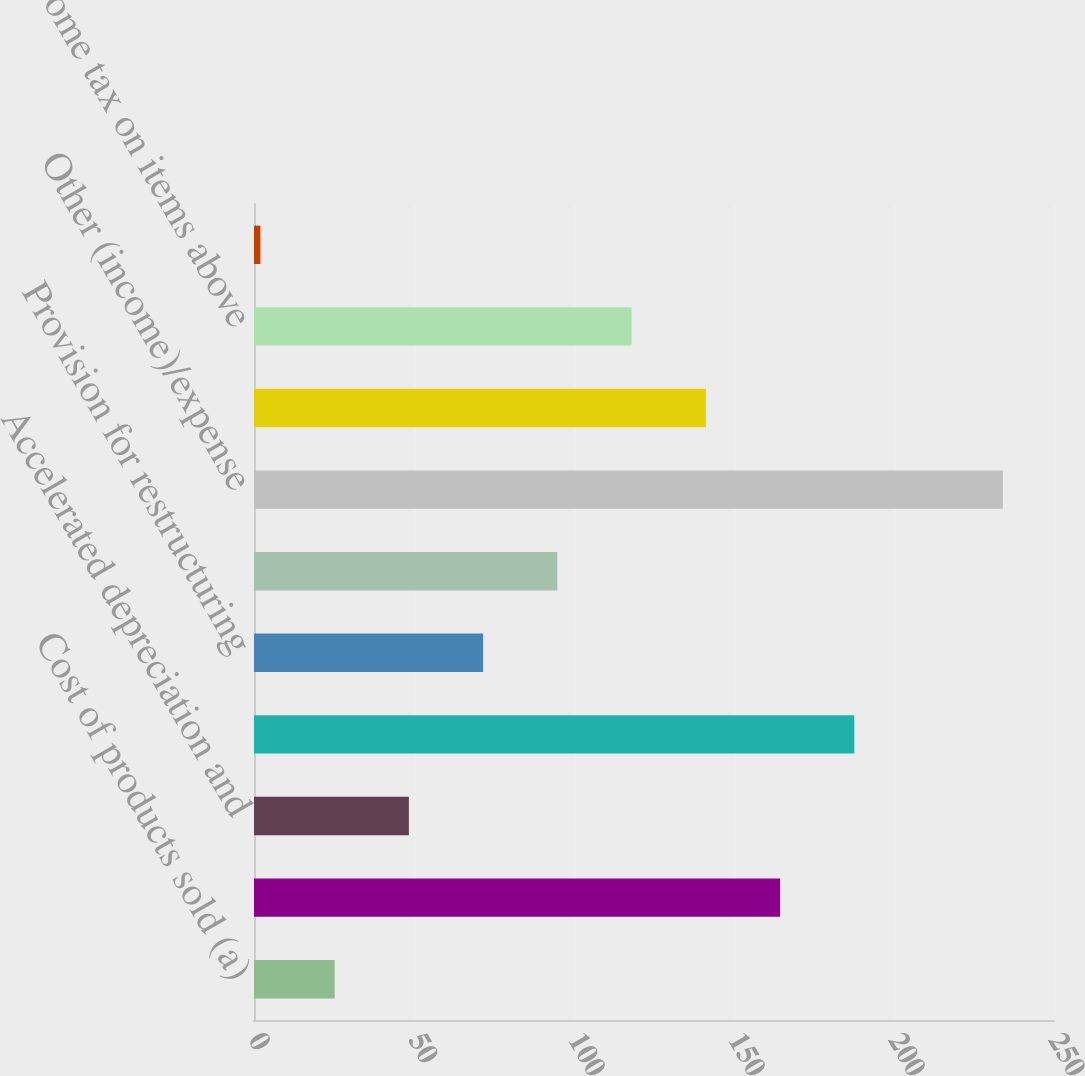<chart> <loc_0><loc_0><loc_500><loc_500><bar_chart><fcel>Cost of products sold (a)<fcel>License and asset acquisition<fcel>Accelerated depreciation and<fcel>Research and development<fcel>Provision for restructuring<fcel>Pension charges<fcel>Other (income)/expense<fcel>Increase/(decrease) to pretax<fcel>Income tax on items above<fcel>Increase/(decrease) to net<nl><fcel>25.2<fcel>164.4<fcel>48.4<fcel>187.6<fcel>71.6<fcel>94.8<fcel>234<fcel>141.2<fcel>118<fcel>2<nl></chart> 